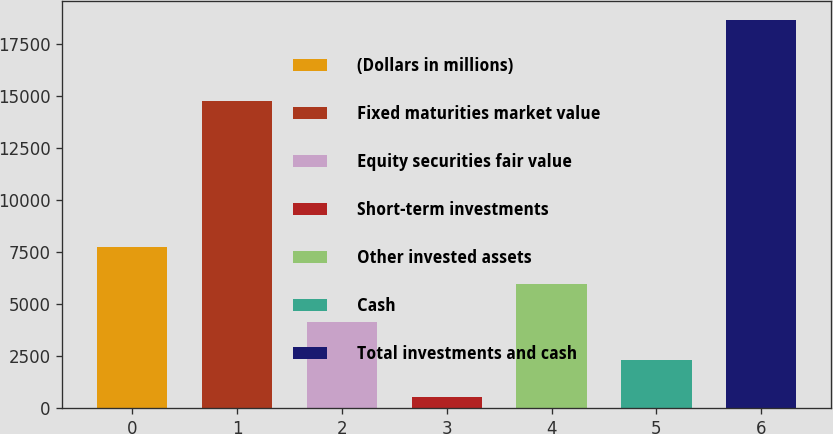Convert chart. <chart><loc_0><loc_0><loc_500><loc_500><bar_chart><fcel>(Dollars in millions)<fcel>Fixed maturities market value<fcel>Equity securities fair value<fcel>Short-term investments<fcel>Other invested assets<fcel>Cash<fcel>Total investments and cash<nl><fcel>7756.42<fcel>14756.8<fcel>4133.06<fcel>509.7<fcel>5944.74<fcel>2321.38<fcel>18626.5<nl></chart> 